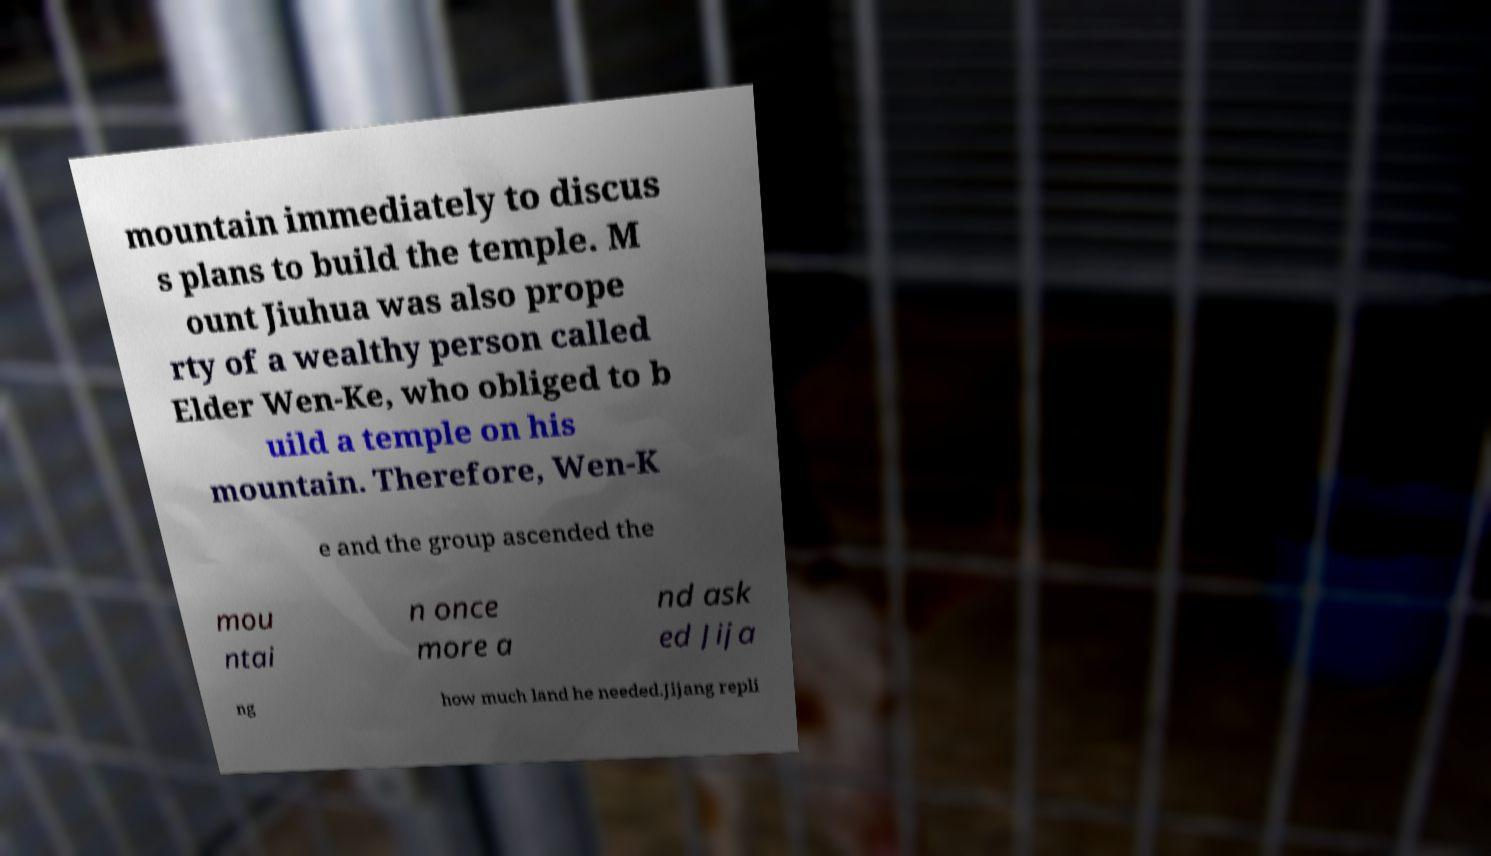Can you accurately transcribe the text from the provided image for me? mountain immediately to discus s plans to build the temple. M ount Jiuhua was also prope rty of a wealthy person called Elder Wen-Ke, who obliged to b uild a temple on his mountain. Therefore, Wen-K e and the group ascended the mou ntai n once more a nd ask ed Jija ng how much land he needed.Jijang repli 